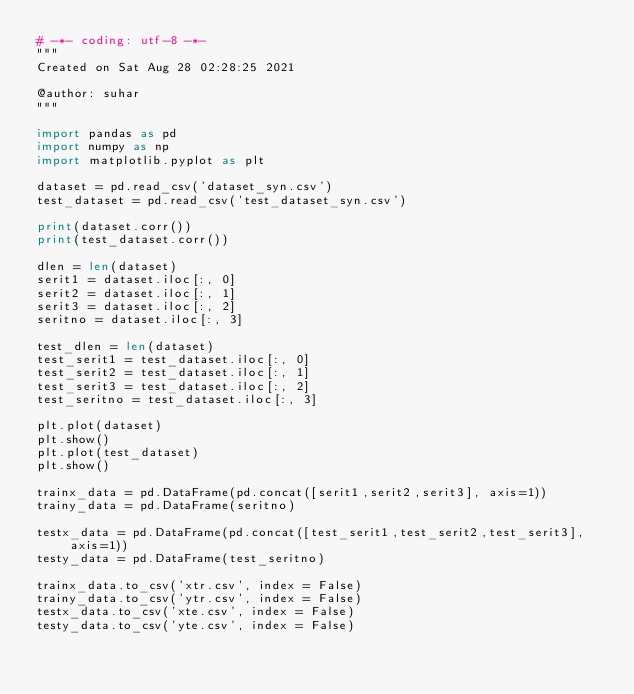Convert code to text. <code><loc_0><loc_0><loc_500><loc_500><_Python_># -*- coding: utf-8 -*-
"""
Created on Sat Aug 28 02:28:25 2021

@author: suhar
"""

import pandas as pd
import numpy as np
import matplotlib.pyplot as plt

dataset = pd.read_csv('dataset_syn.csv')
test_dataset = pd.read_csv('test_dataset_syn.csv')

print(dataset.corr())
print(test_dataset.corr())

dlen = len(dataset)
serit1 = dataset.iloc[:, 0]
serit2 = dataset.iloc[:, 1]
serit3 = dataset.iloc[:, 2]
seritno = dataset.iloc[:, 3]

test_dlen = len(dataset)
test_serit1 = test_dataset.iloc[:, 0]
test_serit2 = test_dataset.iloc[:, 1]
test_serit3 = test_dataset.iloc[:, 2]
test_seritno = test_dataset.iloc[:, 3]

plt.plot(dataset)
plt.show()
plt.plot(test_dataset)
plt.show()

trainx_data = pd.DataFrame(pd.concat([serit1,serit2,serit3], axis=1))
trainy_data = pd.DataFrame(seritno)

testx_data = pd.DataFrame(pd.concat([test_serit1,test_serit2,test_serit3], axis=1))
testy_data = pd.DataFrame(test_seritno)

trainx_data.to_csv('xtr.csv', index = False)
trainy_data.to_csv('ytr.csv', index = False)
testx_data.to_csv('xte.csv', index = False)
testy_data.to_csv('yte.csv', index = False)</code> 